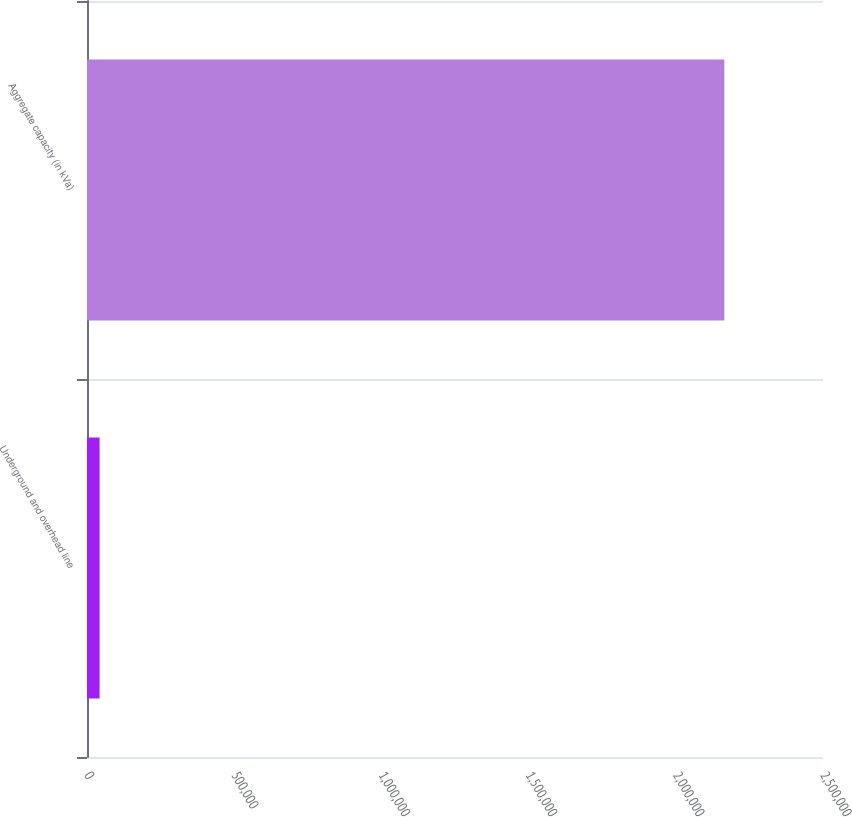Convert chart. <chart><loc_0><loc_0><loc_500><loc_500><bar_chart><fcel>Underground and overhead line<fcel>Aggregate capacity (in kVa)<nl><fcel>42834<fcel>2.16501e+06<nl></chart> 